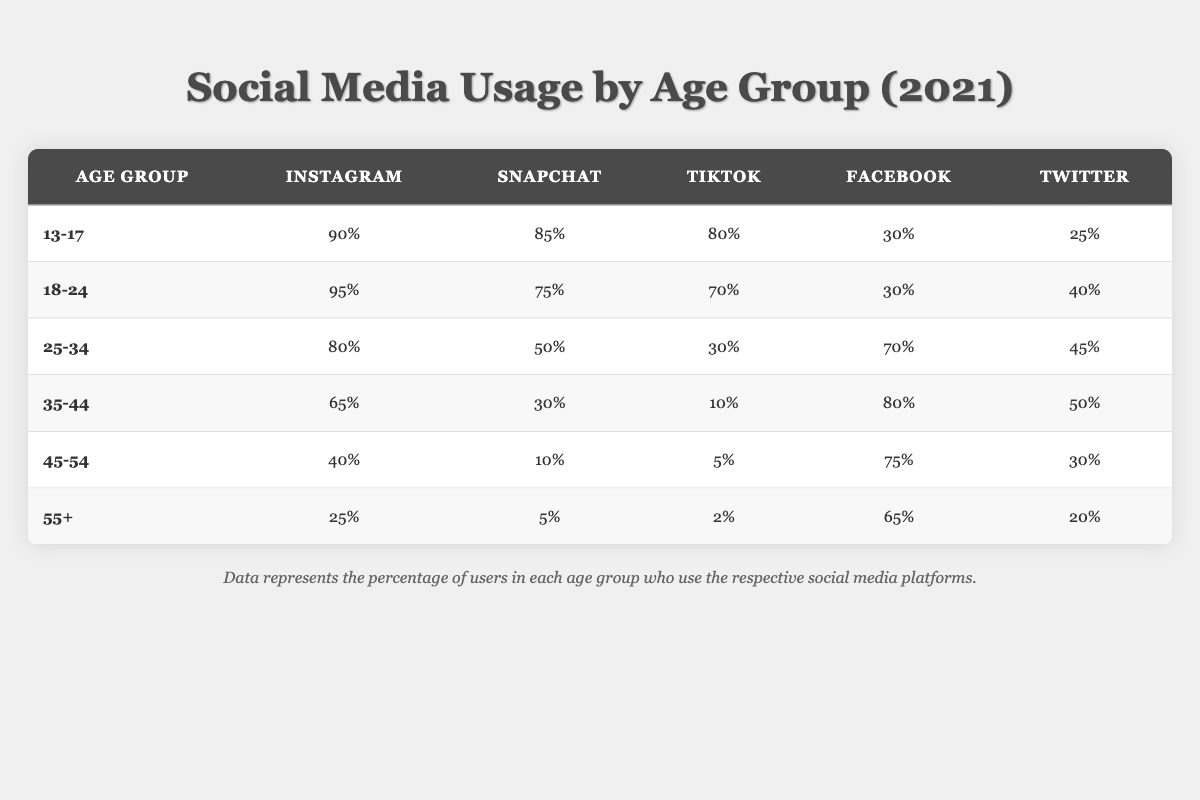What age group has the highest percentage of Instagram users? The table shows that the age group 18-24 has the highest percentage of Instagram users at 95%.
Answer: 18-24 Which platform is used the least by the 55+ age group? Among the platforms listed, the 55+ age group uses TikTok the least, with only 2%.
Answer: TikTok What is the percentage difference in Snapchat usage between the 13-17 and 35-44 age groups? The 13-17 age group uses Snapchat at 85%, while the 35-44 age group uses it at 30%. The difference is 85% - 30% = 55%.
Answer: 55% Which platform is more popular among the 25-34 age group: Facebook or Instagram? The table indicates that the 25-34 age group has a higher usage of Instagram at 80% compared to Facebook at 70%.
Answer: Instagram Do more people aged 45-54 use Facebook than Twitter? The table shows that 75% of the 45-54 age group use Facebook, while only 30% use Twitter. Therefore, more 45-54 year-olds use Facebook.
Answer: Yes What is the average percentage of TikTok usage across all age groups? To find the average, sum the percentages of TikTok usage: (80 + 70 + 30 + 10 + 5 + 2) = 197. Then, divide by the number of age groups (6): 197 / 6 ≈ 32.83.
Answer: 32.83 Which age group uses Snapchat the least? The table indicates that the 55+ age group uses Snapchat the least at 5%.
Answer: 55+ Is it true that the 18-24 age group uses Twitter more than the 35-44 age group? Yes, the 18-24 age group has 40% Twitter usage while the 35-44 age group has 50%, which is higher than the former. Thus, the statement is false.
Answer: No What is the total percentage of Facebook usage across all age groups? The percentages of Facebook usage are: 30 + 30 + 70 + 80 + 75 + 65 = 350%. This is the total percentage across all groups.
Answer: 350% How does TikTok usage among the 45-54 age group compare to that of the 13-17 age group? The 45-54 age group has a TikTok usage of 5%, while the 13-17 age group has 80%. The 13-17 age group uses TikTok significantly more than the 45-54 age group.
Answer: 13-17 uses TikTok more 